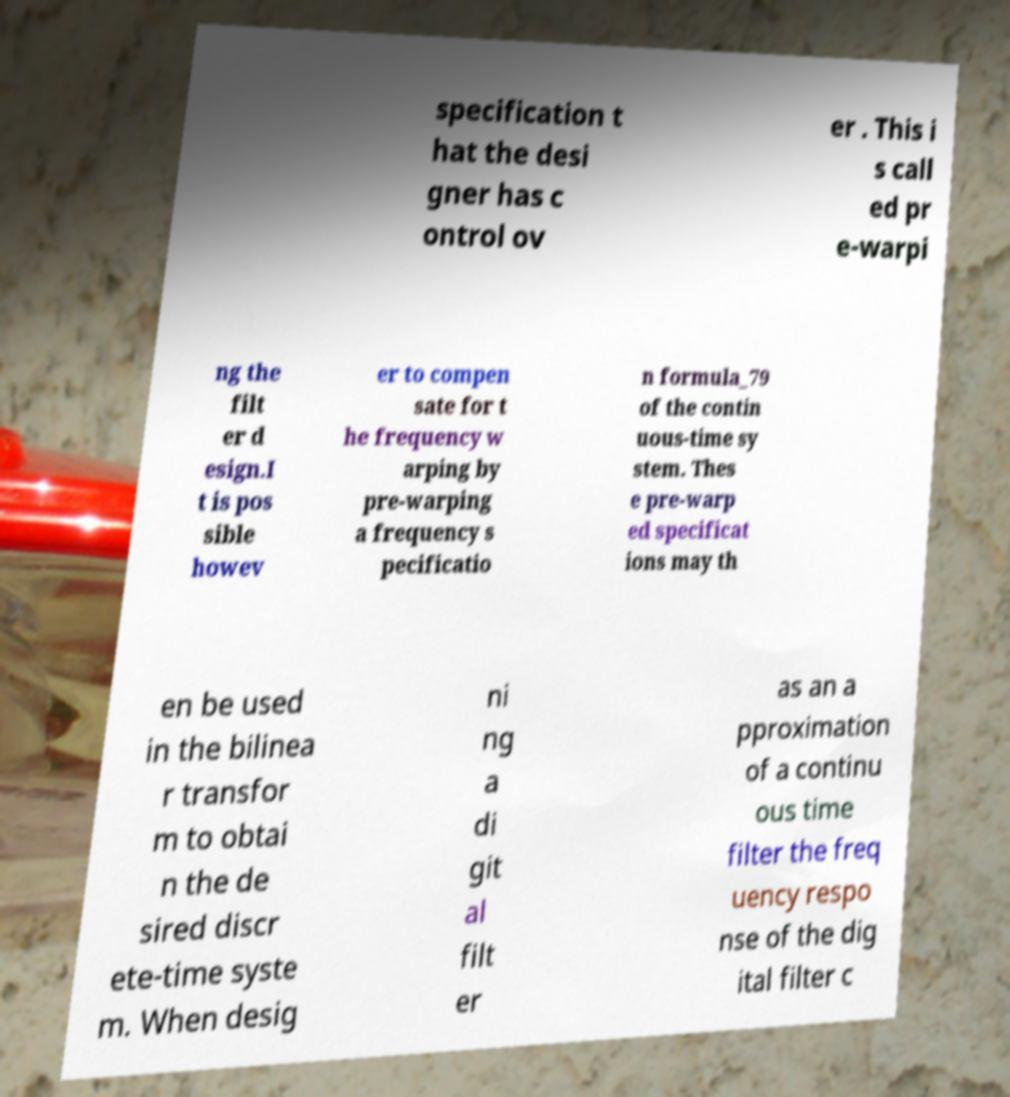Please read and relay the text visible in this image. What does it say? specification t hat the desi gner has c ontrol ov er . This i s call ed pr e-warpi ng the filt er d esign.I t is pos sible howev er to compen sate for t he frequency w arping by pre-warping a frequency s pecificatio n formula_79 of the contin uous-time sy stem. Thes e pre-warp ed specificat ions may th en be used in the bilinea r transfor m to obtai n the de sired discr ete-time syste m. When desig ni ng a di git al filt er as an a pproximation of a continu ous time filter the freq uency respo nse of the dig ital filter c 